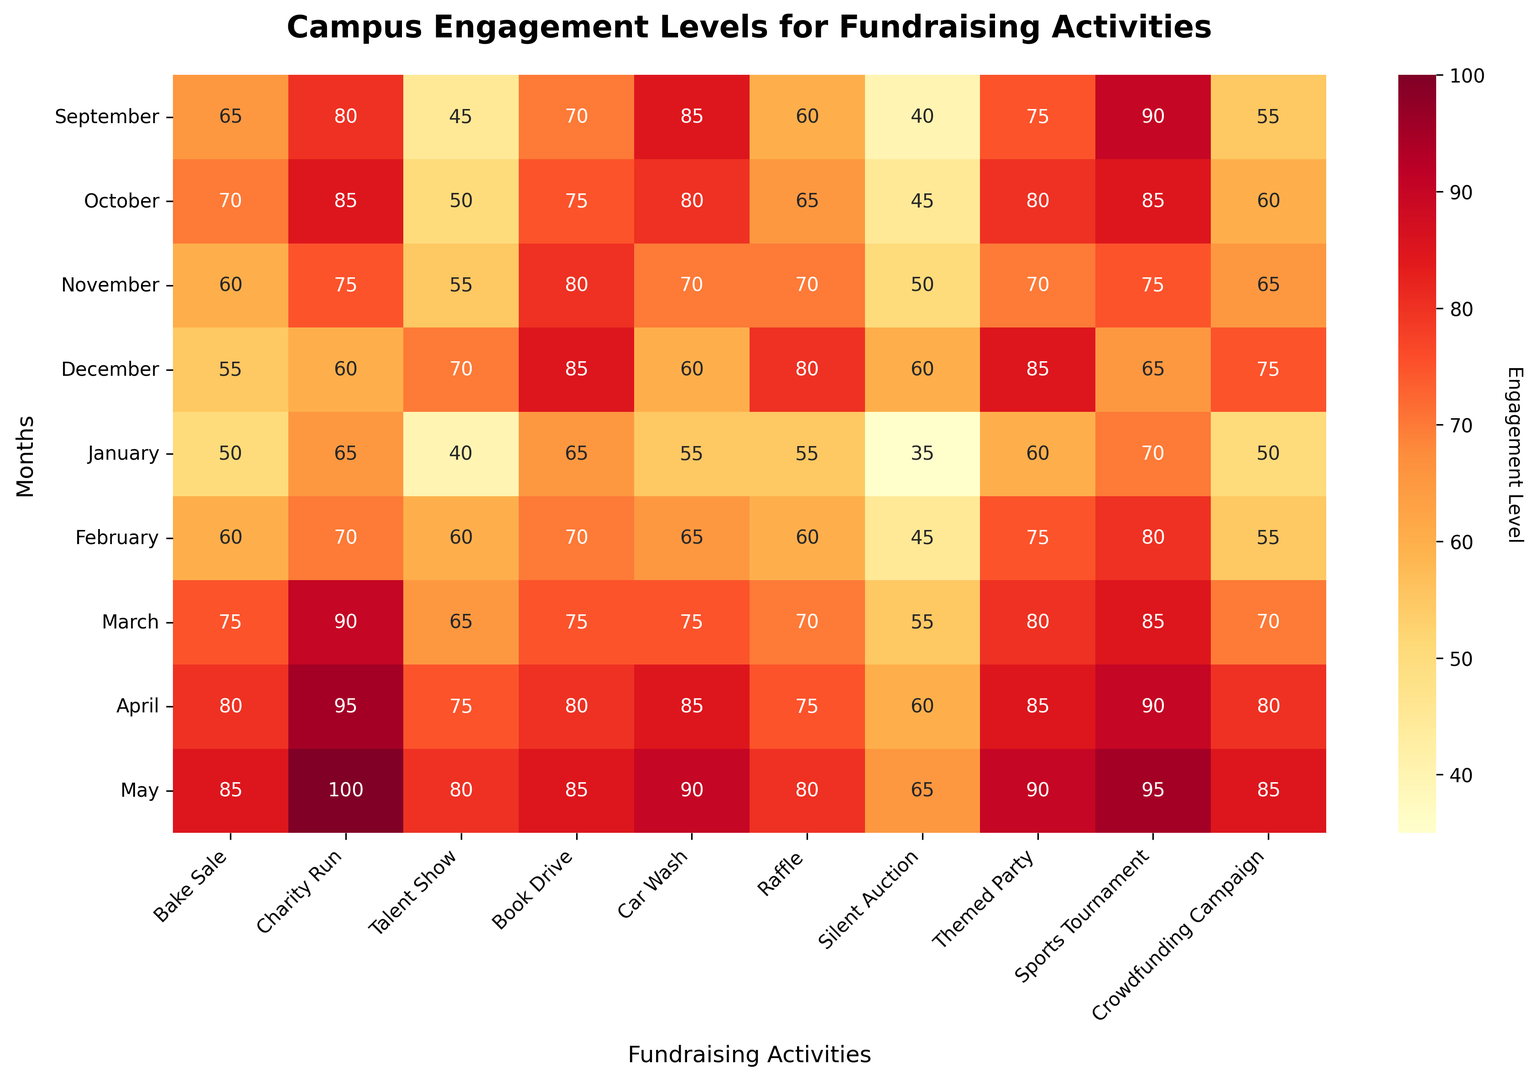What's the highest engagement level across all fundraising activities and months? To find the highest engagement level, look for the cell in the heatmap with the deepest red color and the highest number. Here, it's the value 100 in May for Charity Run.
Answer: 100 Which month has the lowest engagement for the "Talent Show"? Scan the "Talent Show" column for the lowest value. The lowest engagement level is in January with a value of 40.
Answer: January During which month was the engagement for the "Silent Auction" exactly 50? Scan the "Silent Auction" column for a value of 50 and note the corresponding month. It's in November.
Answer: November What is the average engagement level for "Bake Sale" from February to April? Calculate the average: (60 + 75 + 80) / 3 = 215 / 3 = 71.67.
Answer: 71.67 How does the engagement in "Car Wash" in December compare with that in March? Compare the values in the "Car Wash" column for December (60) and March (75). Since 60 is less than 75, engagement in December is lower.
Answer: Lower in December Which activity had the most consistent engagement levels across all months, and what patterns do you observe? Look for the activity column with the least variation. "Raffle" has values ranging from 55 to 80, showing more consistency compared to others.
Answer: Raffle In April, which activity had the second-highest engagement level? Scan April's row for the second-highest value after 95 for Charity Run. The second-highest value is 90 for Sports Tournament.
Answer: Sports Tournament What trend do you observe in engagement levels for "Charity Run" from September to May? Track the values in the "Charity Run" column from September (80) to May (100). The trend shows a steady increase over the months.
Answer: Steady increase Compare the engagement levels for "Themed Party" in December and May. What do you observe? Compare the values for "Themed Party" in December (85) and May (90). Engagement is higher in May.
Answer: Higher in May What is the sum of engagement levels for "Book Drive" from September to January? Add the values for "Book Drive" from September to January: 70 + 75 + 80 + 85 + 65 = 375.
Answer: 375 